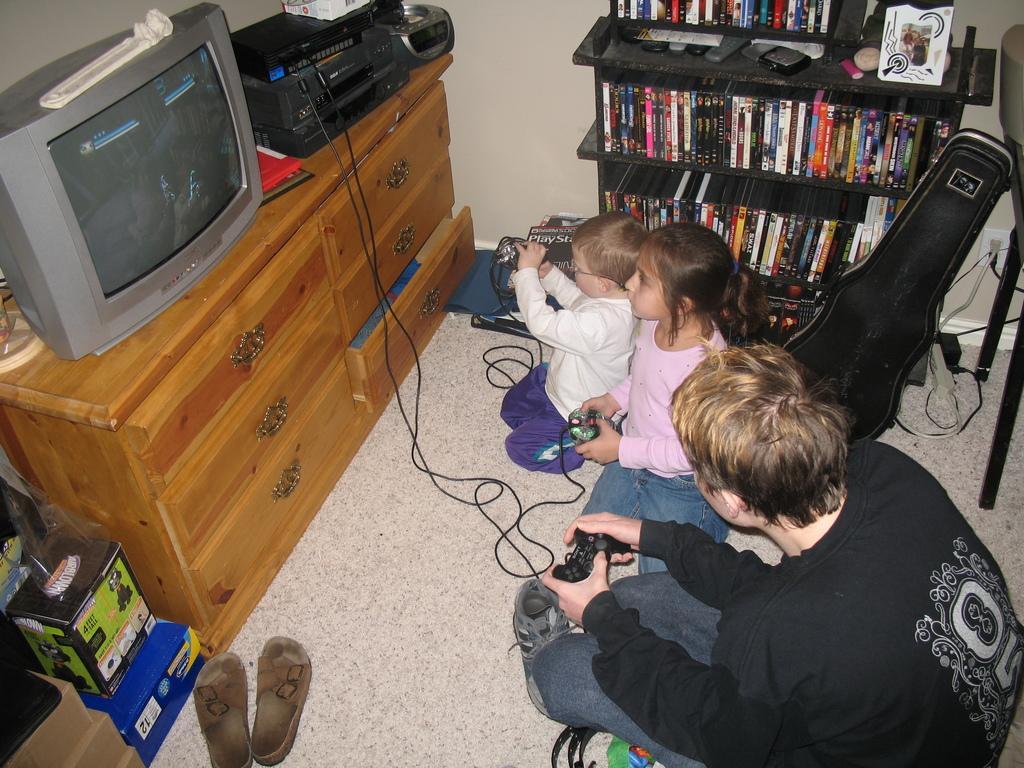How would you summarize this image in a sentence or two? In this image there are group of persons who are playing games at the left side of the image there is a Television and Radio. 